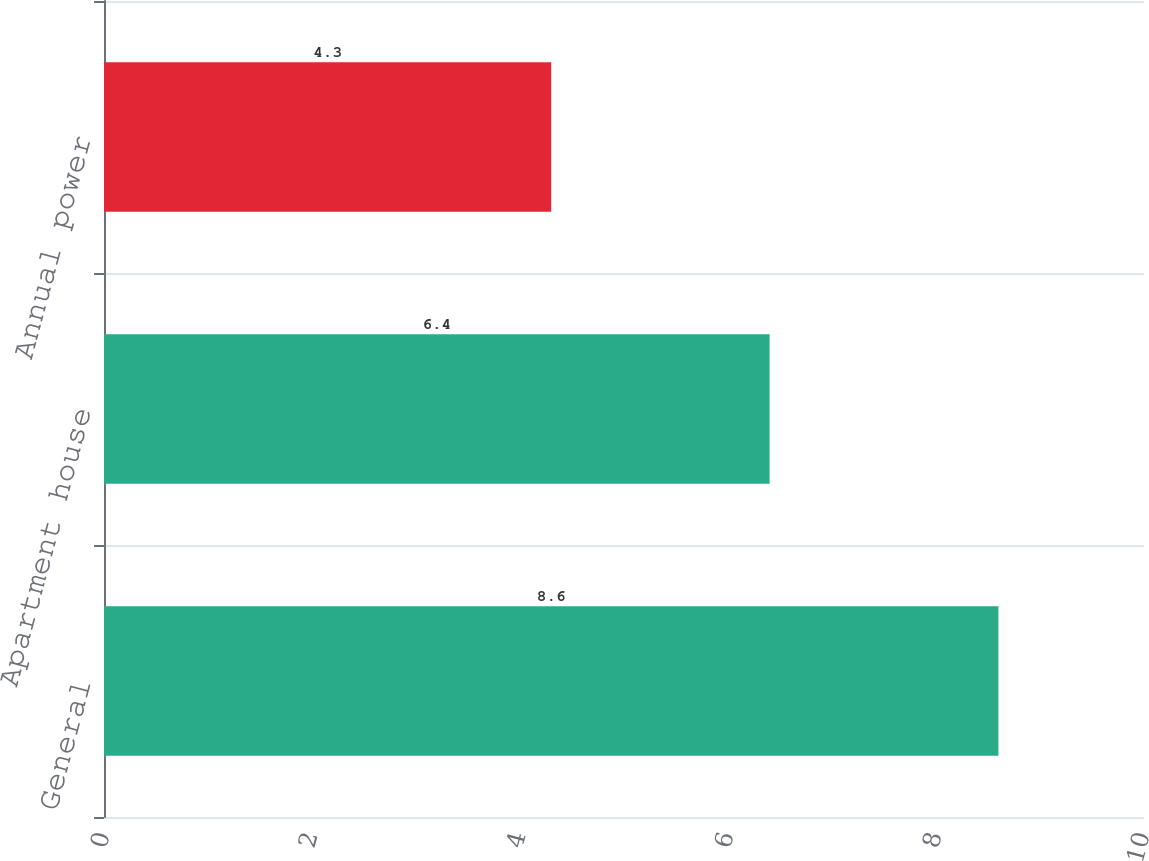Convert chart. <chart><loc_0><loc_0><loc_500><loc_500><bar_chart><fcel>General<fcel>Apartment house<fcel>Annual power<nl><fcel>8.6<fcel>6.4<fcel>4.3<nl></chart> 